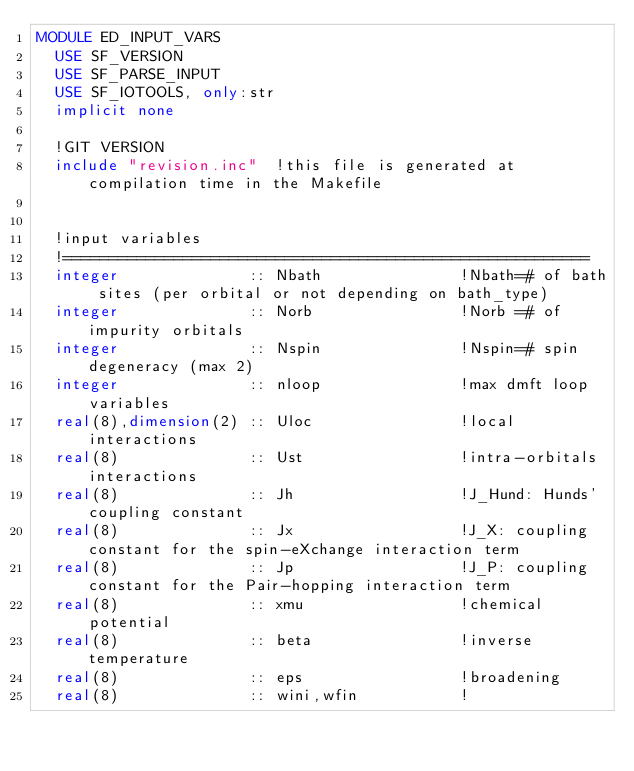Convert code to text. <code><loc_0><loc_0><loc_500><loc_500><_FORTRAN_>MODULE ED_INPUT_VARS
  USE SF_VERSION
  USE SF_PARSE_INPUT
  USE SF_IOTOOLS, only:str
  implicit none

  !GIT VERSION
  include "revision.inc"  !this file is generated at compilation time in the Makefile


  !input variables
  !=========================================================
  integer              :: Nbath               !Nbath=# of bath sites (per orbital or not depending on bath_type)
  integer              :: Norb                !Norb =# of impurity orbitals
  integer              :: Nspin               !Nspin=# spin degeneracy (max 2)
  integer              :: nloop               !max dmft loop variables
  real(8),dimension(2) :: Uloc                !local interactions
  real(8)              :: Ust                 !intra-orbitals interactions
  real(8)              :: Jh                  !J_Hund: Hunds' coupling constant 
  real(8)              :: Jx                  !J_X: coupling constant for the spin-eXchange interaction term
  real(8)              :: Jp                  !J_P: coupling constant for the Pair-hopping interaction term 
  real(8)              :: xmu                 !chemical potential
  real(8)              :: beta                !inverse temperature
  real(8)              :: eps                 !broadening
  real(8)              :: wini,wfin           !</code> 